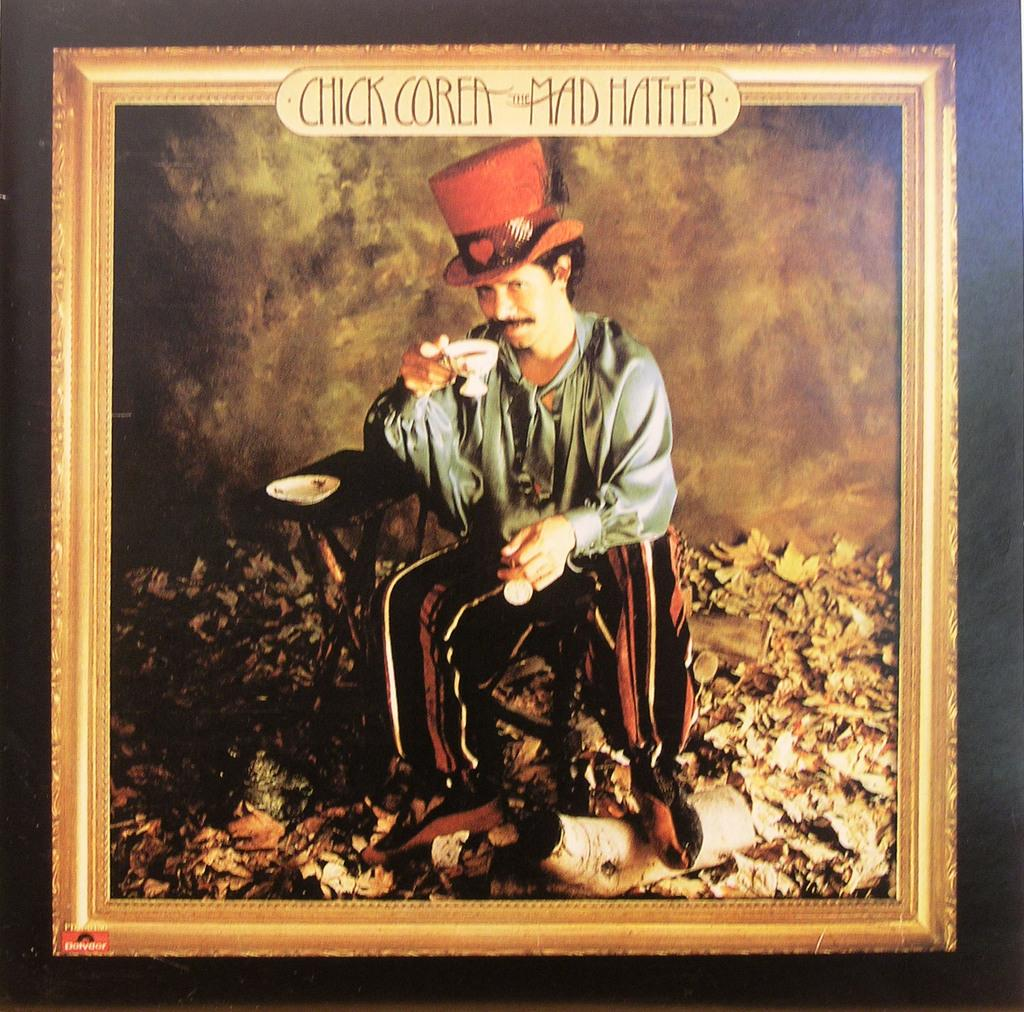Provide a one-sentence caption for the provided image. A painting of a man with the label Chick Corea the mad hatter above him. 